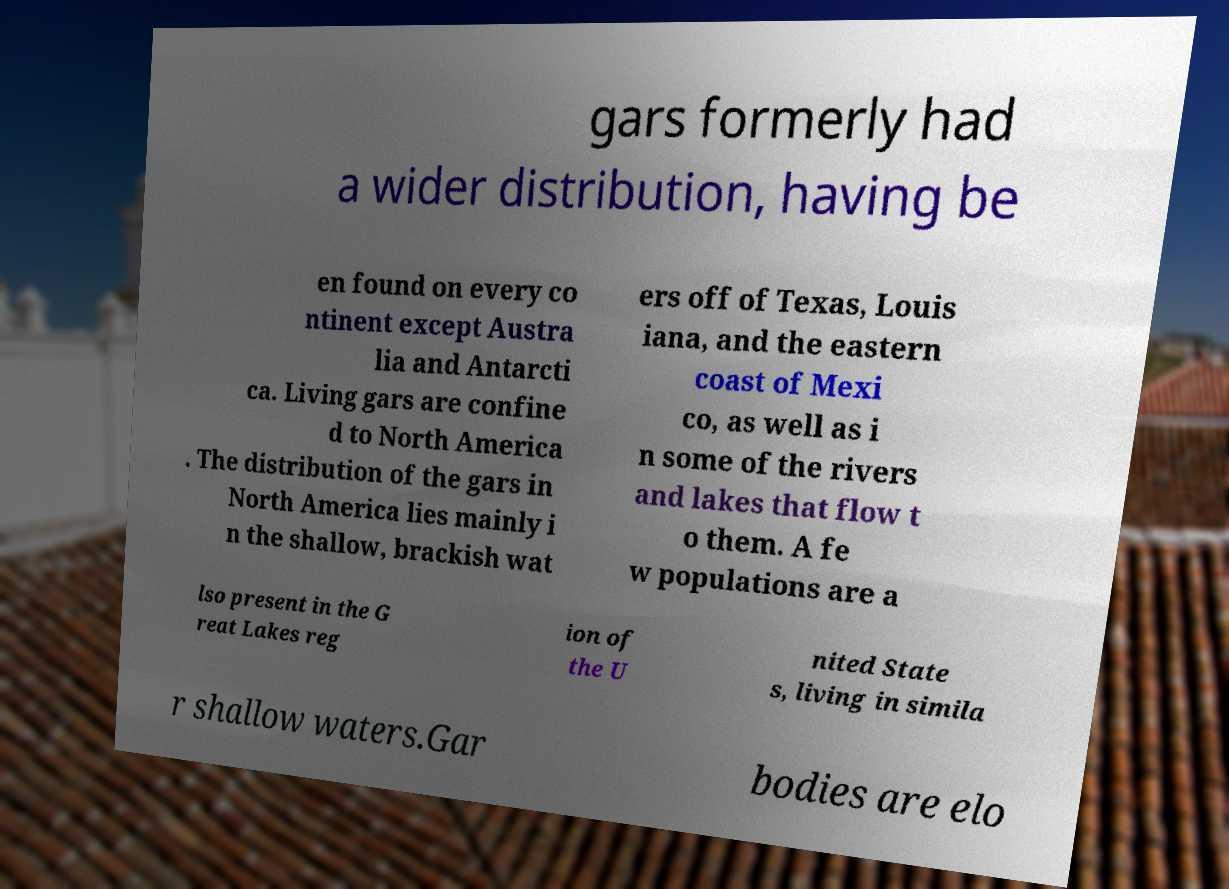Please identify and transcribe the text found in this image. gars formerly had a wider distribution, having be en found on every co ntinent except Austra lia and Antarcti ca. Living gars are confine d to North America . The distribution of the gars in North America lies mainly i n the shallow, brackish wat ers off of Texas, Louis iana, and the eastern coast of Mexi co, as well as i n some of the rivers and lakes that flow t o them. A fe w populations are a lso present in the G reat Lakes reg ion of the U nited State s, living in simila r shallow waters.Gar bodies are elo 